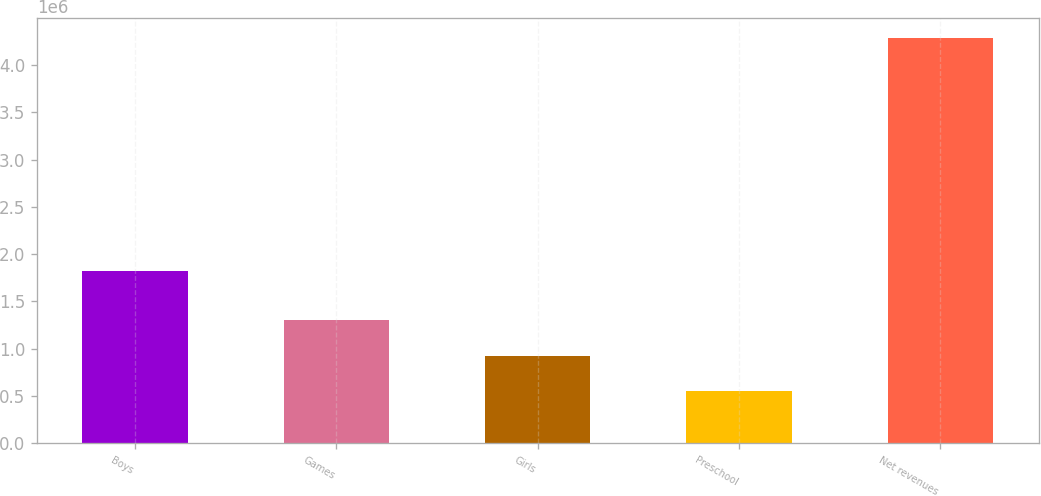Convert chart to OTSL. <chart><loc_0><loc_0><loc_500><loc_500><bar_chart><fcel>Boys<fcel>Games<fcel>Girls<fcel>Preschool<fcel>Net revenues<nl><fcel>1.82154e+06<fcel>1.2995e+06<fcel>926240<fcel>552979<fcel>4.28559e+06<nl></chart> 